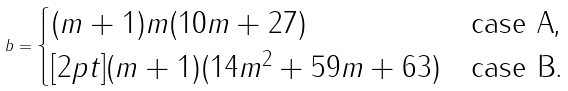Convert formula to latex. <formula><loc_0><loc_0><loc_500><loc_500>b = \begin{cases} ( m + 1 ) m ( 1 0 m + 2 7 ) & \text {case A,} \\ [ 2 p t ] ( m + 1 ) ( 1 4 m ^ { 2 } + 5 9 m + 6 3 ) & \text {case B.} \end{cases}</formula> 